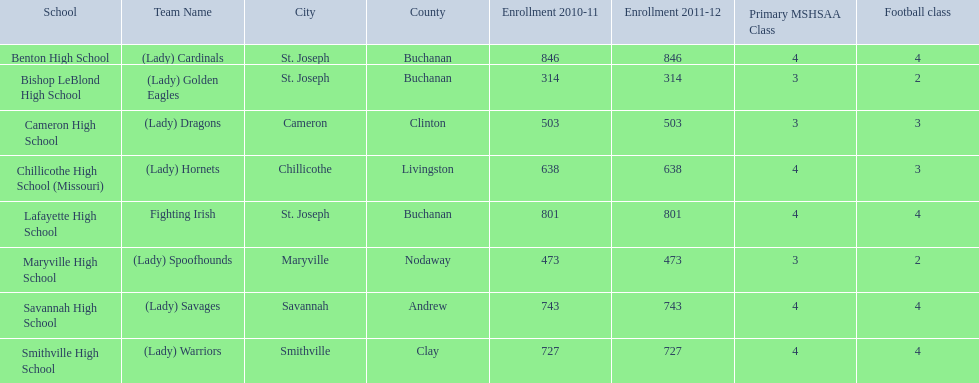What are all of the schools? Benton High School, Bishop LeBlond High School, Cameron High School, Chillicothe High School (Missouri), Lafayette High School, Maryville High School, Savannah High School, Smithville High School. How many football classes do they have? 4, 2, 3, 3, 4, 2, 4, 4. What about their enrollment? 846, 314, 503, 638, 801, 473, 743, 727. Which schools have 3 football classes? Cameron High School, Chillicothe High School (Missouri). And of those schools, which has 638 students? Chillicothe High School (Missouri). 